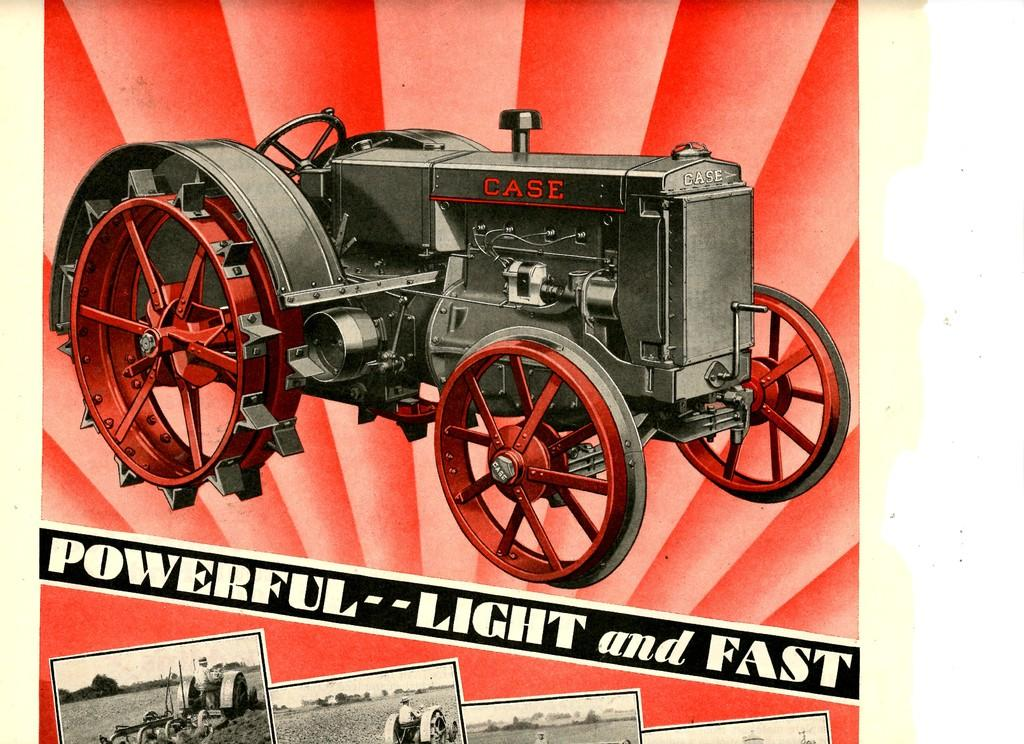What is the main subject of the image? The image contains an advertisement poster. What is depicted on the poster? There is a tractor depicted on the poster. Are there any additional images on the poster? Yes, there are pictures at the bottom of the poster. What else can be found on the poster besides images? There is text present on the poster. Can you see any wilderness in the image? There is no wilderness present in the image; it features an advertisement poster with a tractor and other images. What type of hat is the fairy wearing in the image? There are no fairies or hats present in the image. 